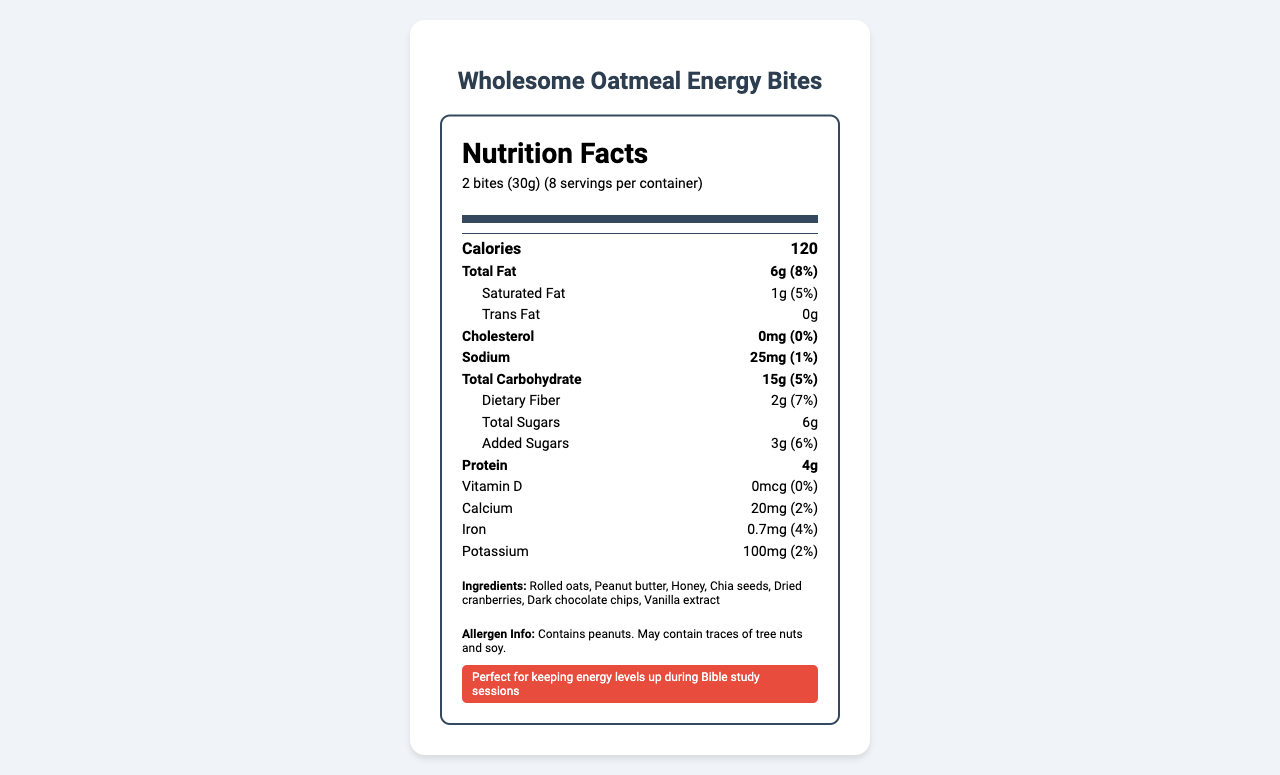How many calories are in a serving of Wholesome Oatmeal Energy Bites? The Nutrition Facts section shows that there are 120 calories per serving.
Answer: 120 How much protein is in a serving? According to the Nutrition Facts, each serving contains 4 grams of protein.
Answer: 4g What is the serving size of the Wholesome Oatmeal Energy Bites? The serving size is specified as 2 bites, which is equivalent to 30 grams.
Answer: 2 bites (30g) How many servings are in one container? The label indicates that there are 8 servings per container.
Answer: 8 What are the main ingredients in Wholesome Oatmeal Energy Bites? The Ingredients list provides the main ingredients.
Answer: Rolled oats, Peanut butter, Honey, Chia seeds, Dried cranberries, Dark chocolate chips, Vanilla extract How much dietary fiber does one serving provide? The Nutrition Facts state that there are 2 grams of dietary fiber per serving.
Answer: 2g What percentage of the daily value of saturated fat does one serving contain? The saturated fat content is 1 gram, which is 5% of the daily value.
Answer: 5% Does this product contain any trans fat? The Nutrition Facts show 0 grams of trans fat.
Answer: No Is this snack suitable for individuals with peanut allergies? The Allergen Info section states that the product contains peanuts and may contain traces of tree nuts and soy.
Answer: No What percentage of the daily value of iron does one serving provide? The Nutrition Facts indicate that the iron content per serving is 0.7mg, which is 4% of the daily value.
Answer: 4% Which nutrient is provided in the highest amount in terms of the daily value percentage? A. Sodium B. Dietary Fiber C. Added Sugars D. Calcium The dietary fiber provides 7% of the daily value, the highest among the listed options.
Answer: B. Dietary Fiber What is one of the nutritional highlights mentioned on the label? A. No added sugars B. Low sodium C. Good source of fiber D. High calcium One of the nutritional highlights is that it is a good source of fiber.
Answer: C. Good source of fiber Does the product contain any artificial preservatives? Under nutritional highlights, it is stated that the product has no artificial preservatives.
Answer: No What is the main message conveyed by the document? The document includes a nutrition facts label, ingredient list, allergen information, and nutritional highlights, emphasizing that the snack is nutritious and suitable for youth group activities.
Answer: The document provides detailed nutritional information about Wholesome Oatmeal Energy Bites, including serving size, calories, nutrient content, ingredients, and special highlights, making it a suitable snack for youth group meetings. Where is the product manufactured? The Nutrition Facts label does not provide a specific manufacturing location other than it being made by the Youth Ministry Kitchen at St. Mark's Church.
Answer: Cannot be determined 